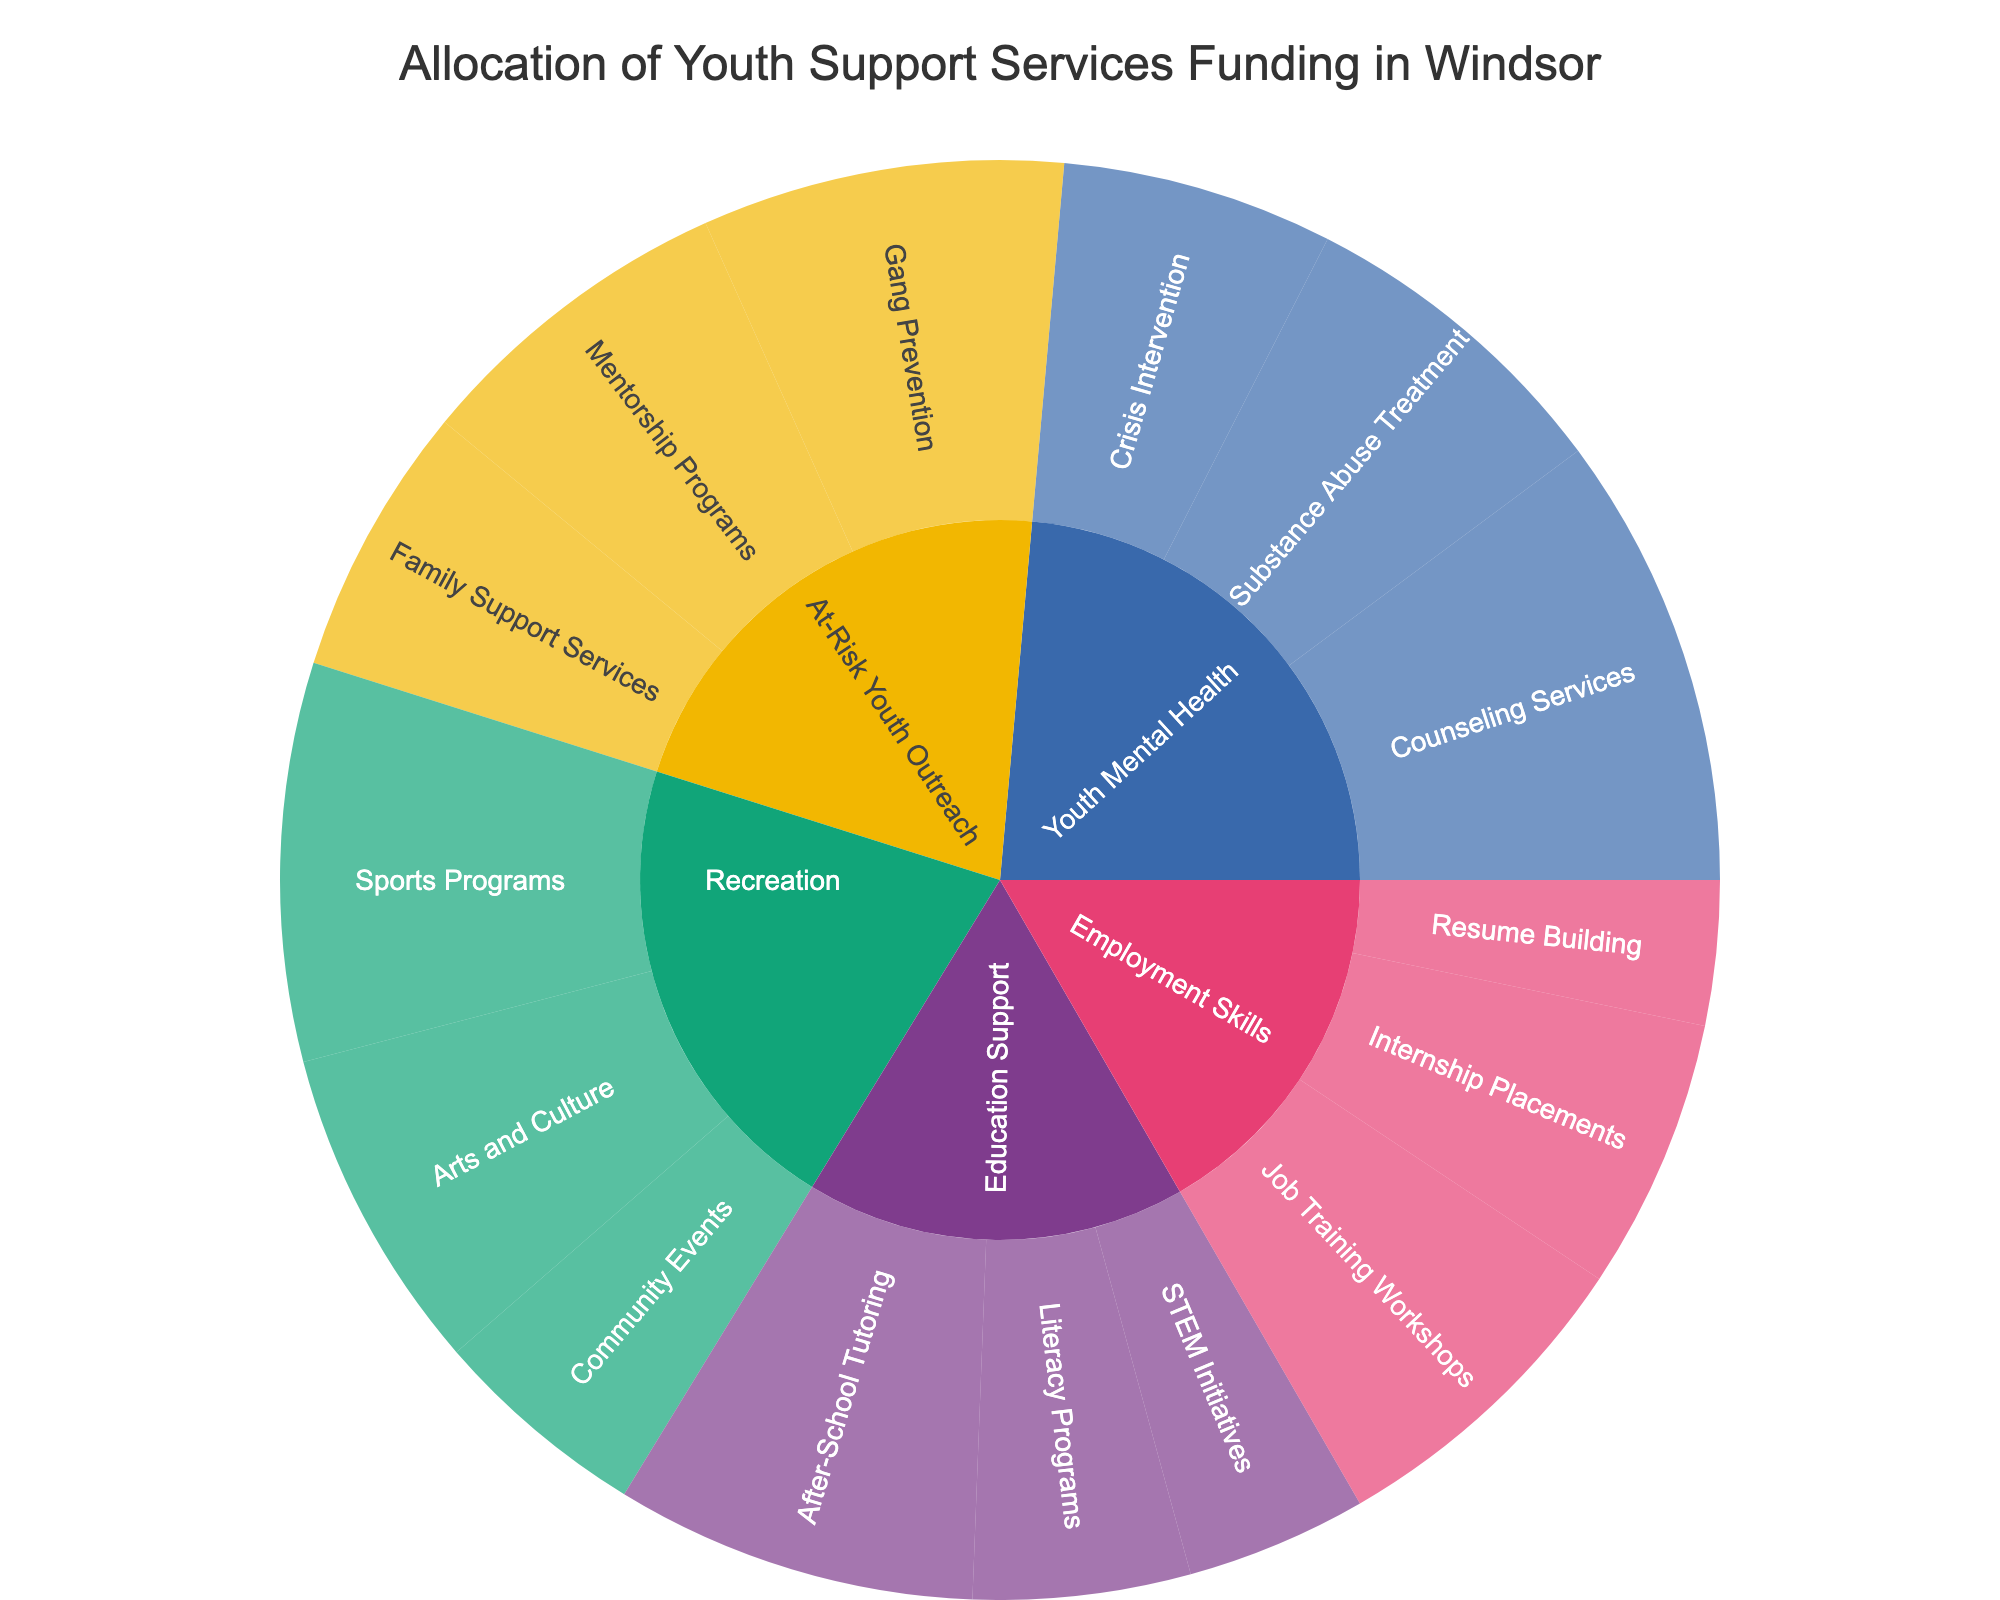What is the title of the plot? The title is usually displayed at the top center of the plot. Here, it would provide an overview of what the plot represents.
Answer: Allocation of Youth Support Services Funding in Windsor How much funding is allocated to the Literacy Programs subprogram? The funding can be seen by hovering over the appropriate section in the sunburst plot, which would show the amount dedicated to Literacy Programs.
Answer: $120,000 Which program receives the most overall funding? Look at the first level of the sunburst plot and compare the total funding for each program. The one with the largest segment represents the highest funding.
Answer: Youth Mental Health What is the total funding for the Employment Skills program? Sum the funding of all subprograms under Employment Skills: Job Training Workshops ($180K), Internship Placements ($150K), and Resume Building ($80K). This gives us $180,000 + $150,000 + $80,000.
Answer: $410,000 Which subprogram under Youth Mental Health has the highest funding? Look at the branches extending from Youth Mental Health and compare the amounts. Counseling Services will have the largest segment if it has the highest funding.
Answer: Counseling Services What is the sum of funding for all subprograms under At-Risk Youth Outreach? Add the funding from all subprograms under At-Risk Youth Outreach: Gang Prevention ($200K), Mentorship Programs ($180K), Family Support Services ($150K). The calculation is $200,000 + $180,000 + $150,000.
Answer: $530,000 Which program has more funding: Education Support or Recreation? Compare the total funding allocated to Education Support and Recreation by looking at the overall size of their segments in the sunburst plot. Compare their respective values.
Answer: Education Support How much more funding does the Sports Programs subprogram have compared to the Arts and Culture subprogram? Subtract the funding for Arts and Culture ($180,000) from the funding for Sports Programs ($220,000): $220,000 - $180,000.
Answer: $40,000 Which program allocates more funds to subprogram targeted activities: Youth Mental Health or Recreation? Sum the funds of all subprograms under each program and compare their totals by comparing the respective segments for Youth Mental Health and Recreation.
Answer: Youth Mental Health 